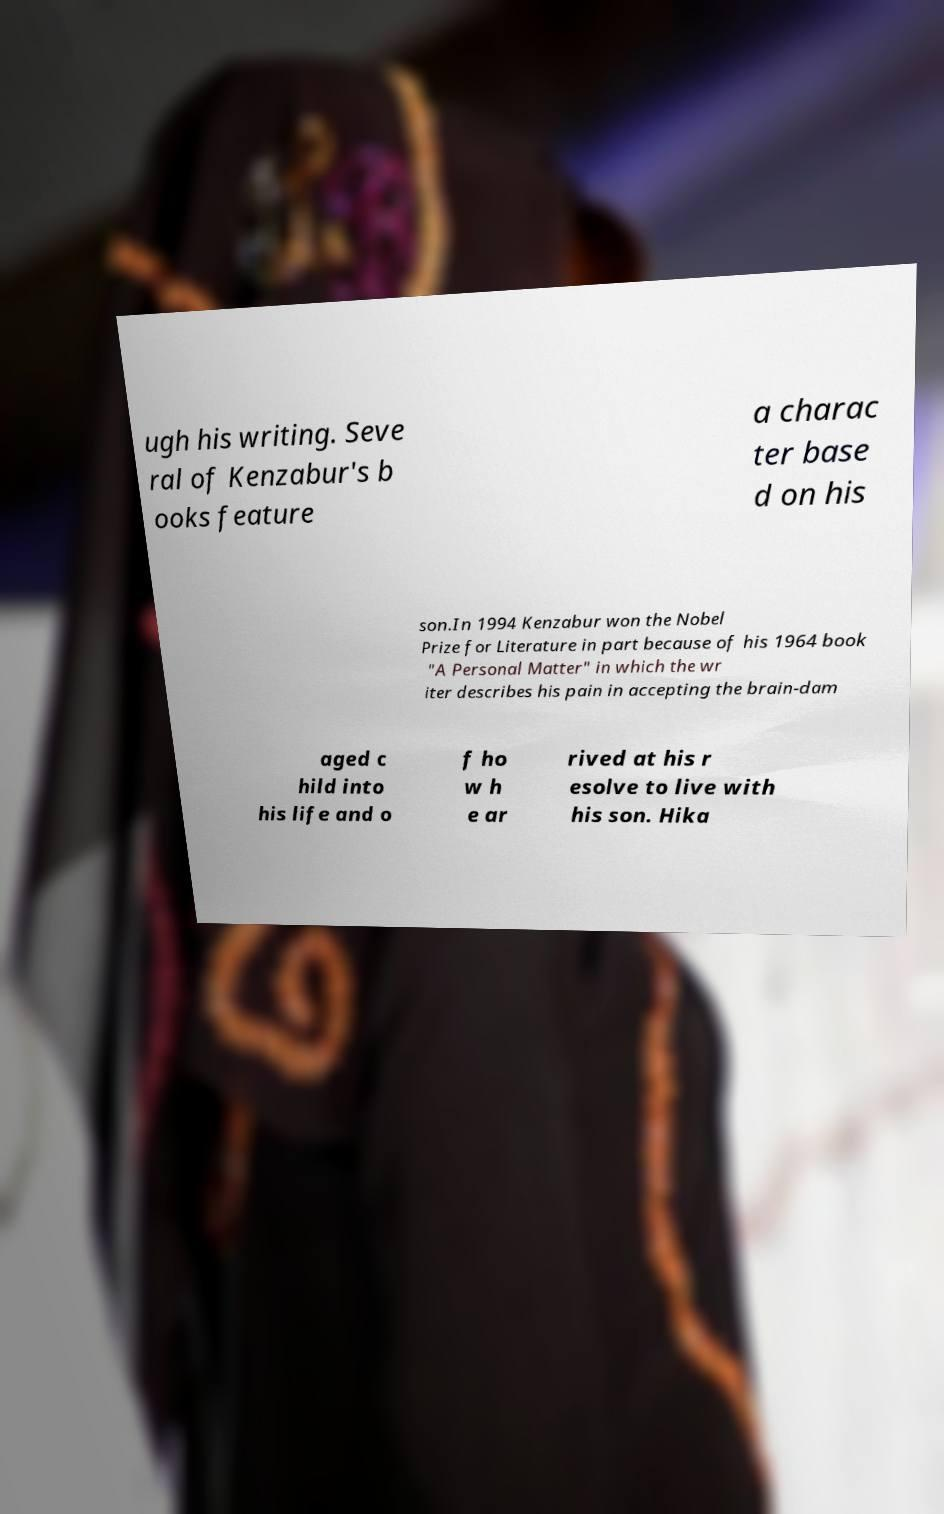Can you read and provide the text displayed in the image?This photo seems to have some interesting text. Can you extract and type it out for me? ugh his writing. Seve ral of Kenzabur's b ooks feature a charac ter base d on his son.In 1994 Kenzabur won the Nobel Prize for Literature in part because of his 1964 book "A Personal Matter" in which the wr iter describes his pain in accepting the brain-dam aged c hild into his life and o f ho w h e ar rived at his r esolve to live with his son. Hika 